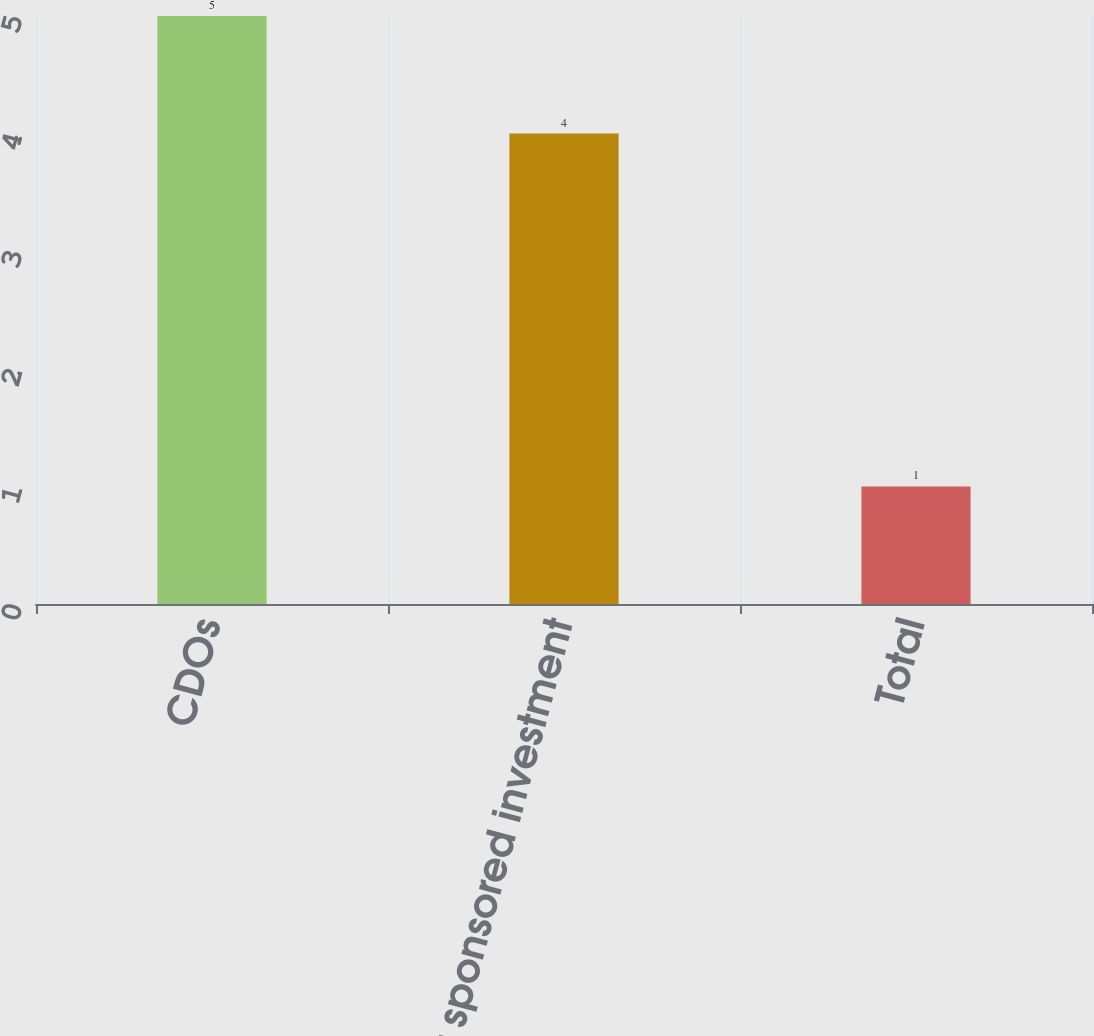Convert chart. <chart><loc_0><loc_0><loc_500><loc_500><bar_chart><fcel>CDOs<fcel>Other sponsored investment<fcel>Total<nl><fcel>5<fcel>4<fcel>1<nl></chart> 